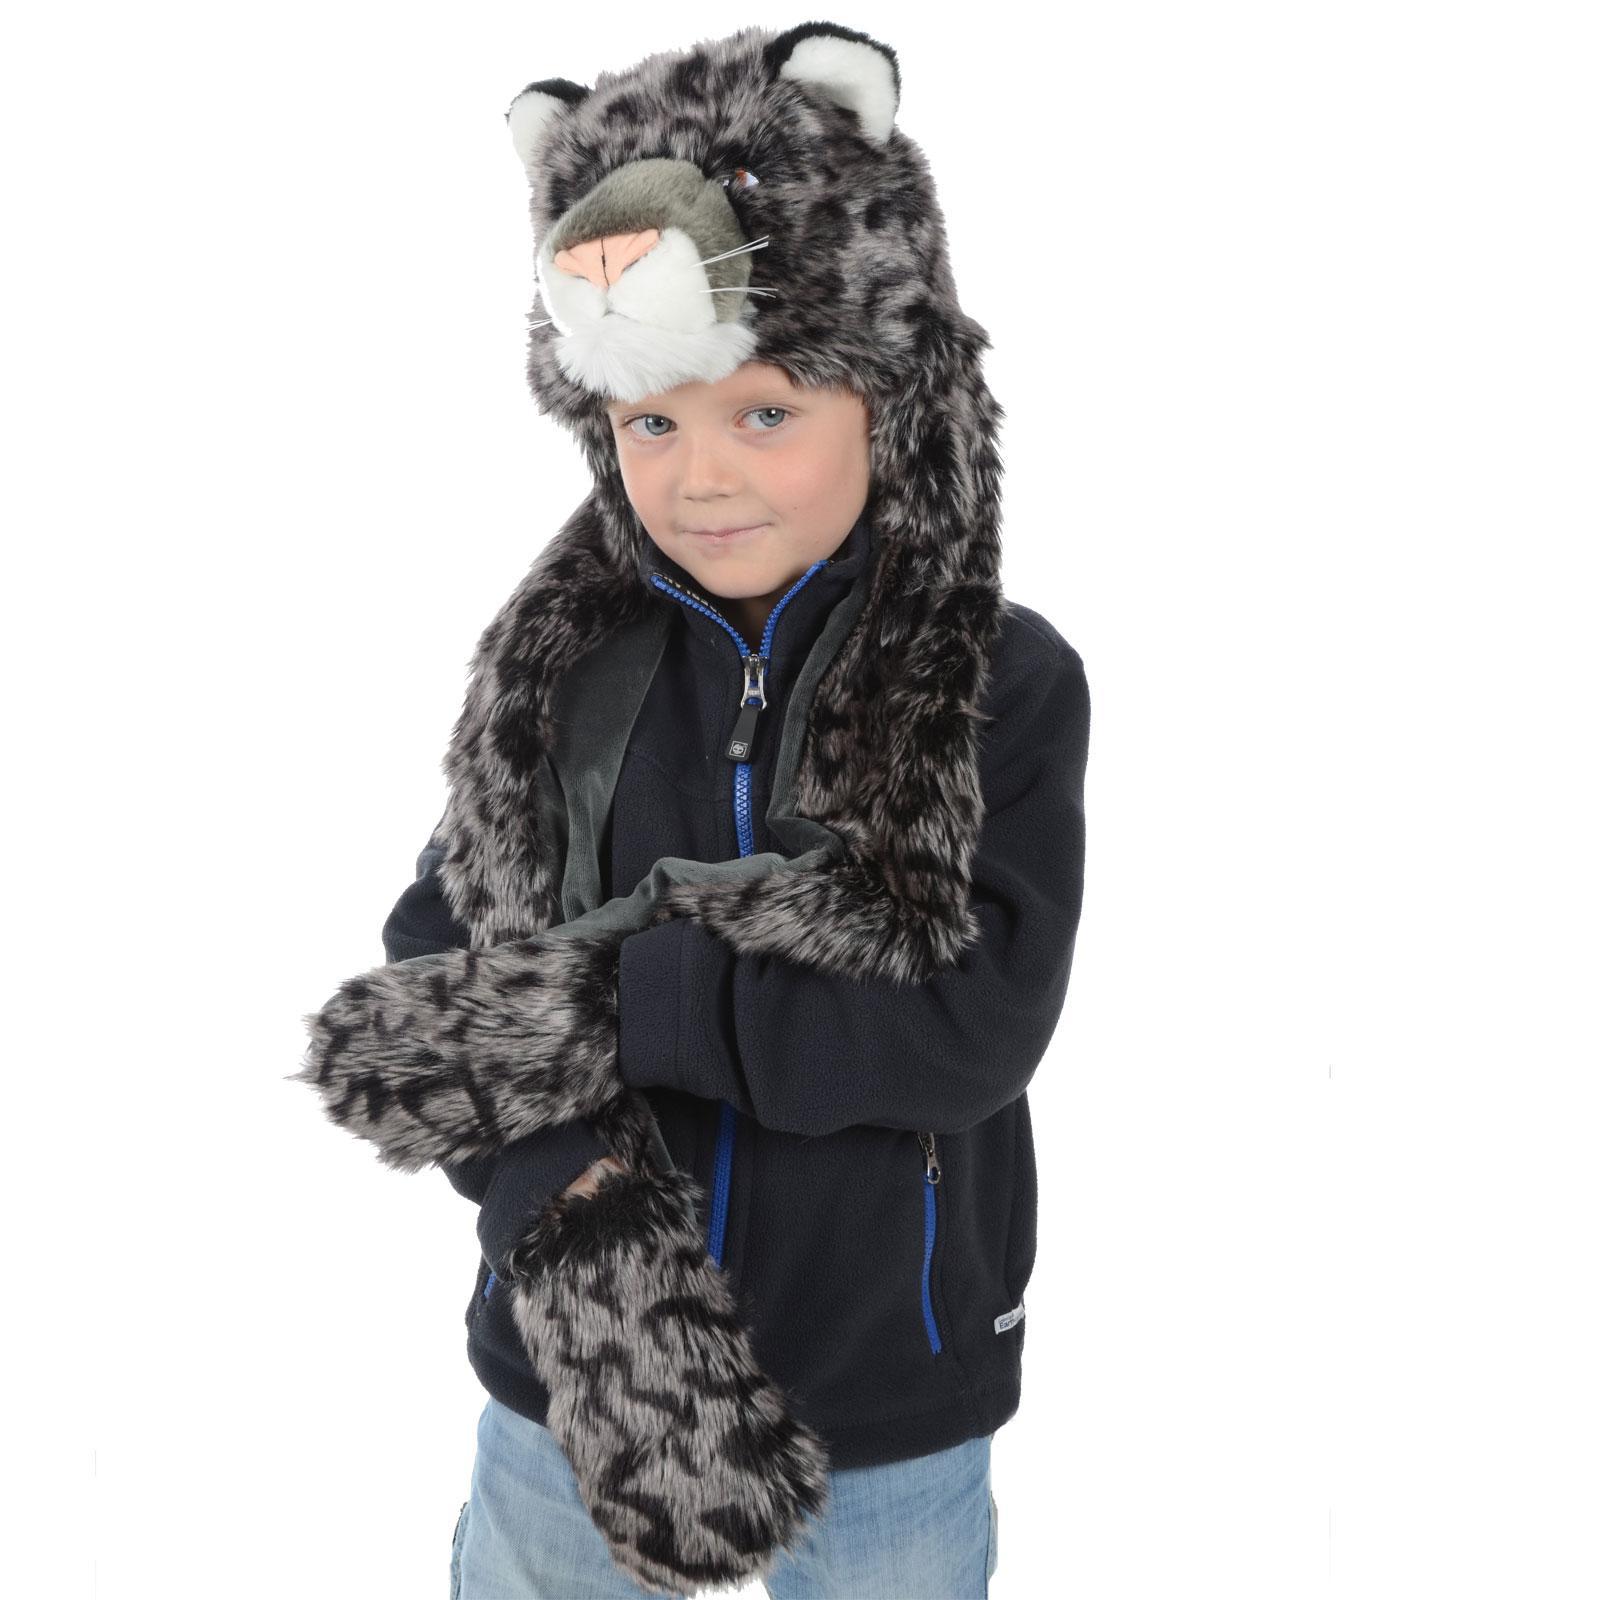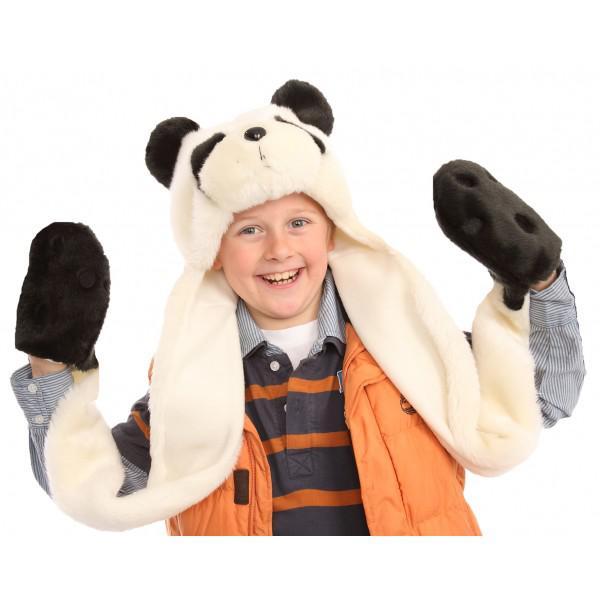The first image is the image on the left, the second image is the image on the right. For the images displayed, is the sentence "A young Asian woman in a pale knit top is holding at least one paw-decorated mitten up to the camera." factually correct? Answer yes or no. No. 